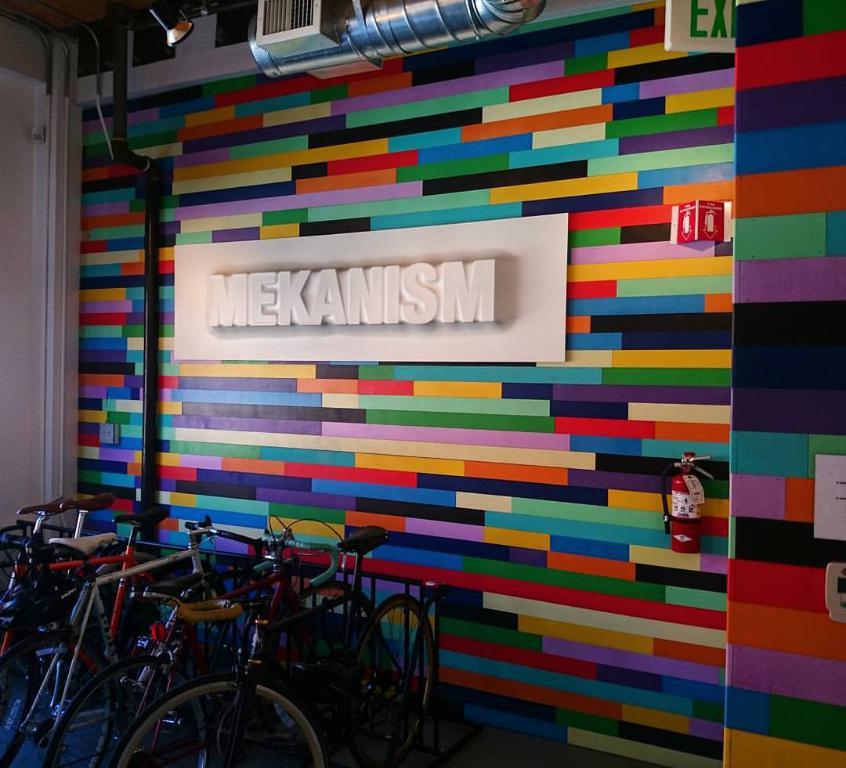What is the word in white?
Keep it short and to the point. Mekanism. What does the sign in the upper right say?
Your answer should be very brief. Exit. 